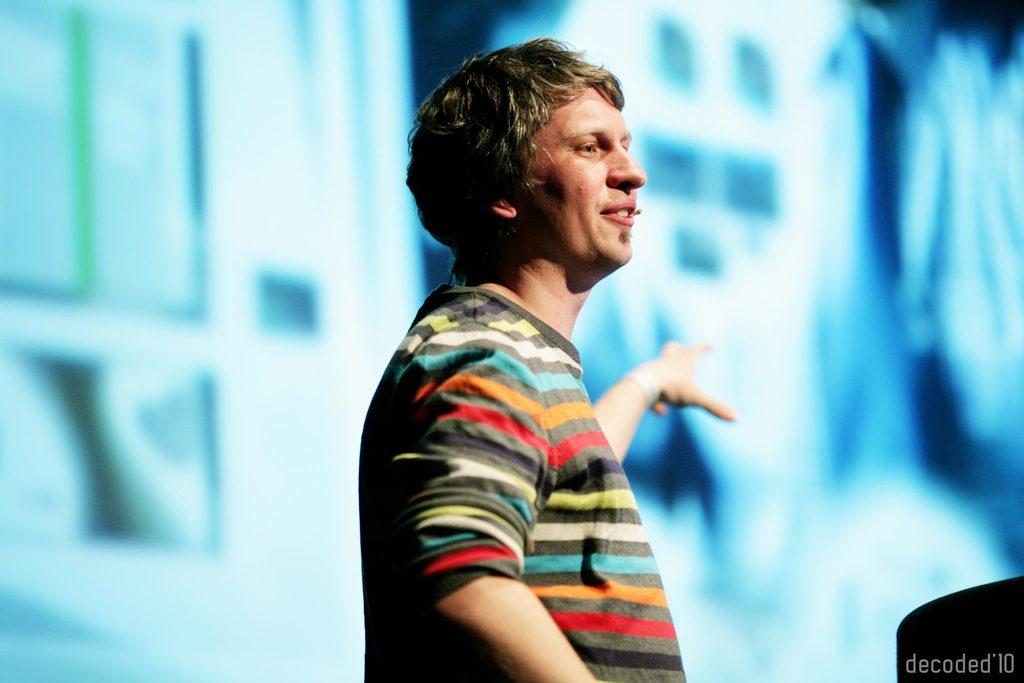Who or what is the main subject in the image? There is a person in the image. What can be observed about the background of the image? The background of the image is blurred. Is there any text present in the image? Yes, there is text in the bottom right corner of the image. What type of land can be seen in the background of the image? There is no land visible in the background of the image, as it is blurred. Can you tell me how the person is using magic in the image? There is no magic or any indication of magical abilities in the image; it simply features a person. 